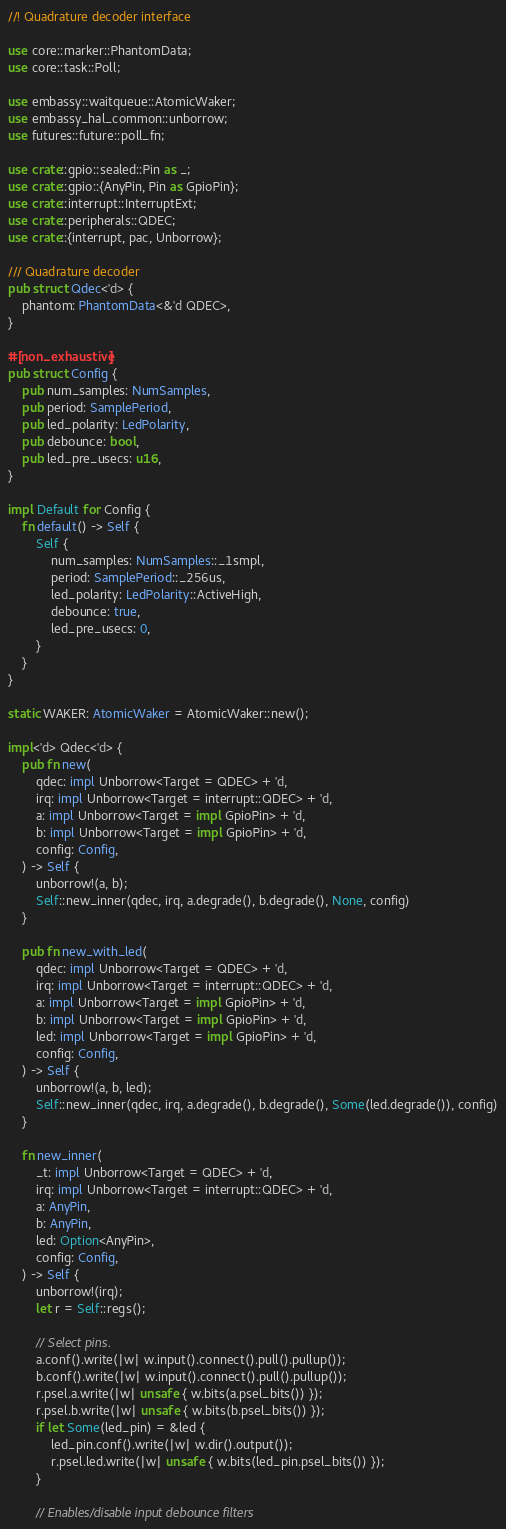<code> <loc_0><loc_0><loc_500><loc_500><_Rust_>//! Quadrature decoder interface

use core::marker::PhantomData;
use core::task::Poll;

use embassy::waitqueue::AtomicWaker;
use embassy_hal_common::unborrow;
use futures::future::poll_fn;

use crate::gpio::sealed::Pin as _;
use crate::gpio::{AnyPin, Pin as GpioPin};
use crate::interrupt::InterruptExt;
use crate::peripherals::QDEC;
use crate::{interrupt, pac, Unborrow};

/// Quadrature decoder
pub struct Qdec<'d> {
    phantom: PhantomData<&'d QDEC>,
}

#[non_exhaustive]
pub struct Config {
    pub num_samples: NumSamples,
    pub period: SamplePeriod,
    pub led_polarity: LedPolarity,
    pub debounce: bool,
    pub led_pre_usecs: u16,
}

impl Default for Config {
    fn default() -> Self {
        Self {
            num_samples: NumSamples::_1smpl,
            period: SamplePeriod::_256us,
            led_polarity: LedPolarity::ActiveHigh,
            debounce: true,
            led_pre_usecs: 0,
        }
    }
}

static WAKER: AtomicWaker = AtomicWaker::new();

impl<'d> Qdec<'d> {
    pub fn new(
        qdec: impl Unborrow<Target = QDEC> + 'd,
        irq: impl Unborrow<Target = interrupt::QDEC> + 'd,
        a: impl Unborrow<Target = impl GpioPin> + 'd,
        b: impl Unborrow<Target = impl GpioPin> + 'd,
        config: Config,
    ) -> Self {
        unborrow!(a, b);
        Self::new_inner(qdec, irq, a.degrade(), b.degrade(), None, config)
    }

    pub fn new_with_led(
        qdec: impl Unborrow<Target = QDEC> + 'd,
        irq: impl Unborrow<Target = interrupt::QDEC> + 'd,
        a: impl Unborrow<Target = impl GpioPin> + 'd,
        b: impl Unborrow<Target = impl GpioPin> + 'd,
        led: impl Unborrow<Target = impl GpioPin> + 'd,
        config: Config,
    ) -> Self {
        unborrow!(a, b, led);
        Self::new_inner(qdec, irq, a.degrade(), b.degrade(), Some(led.degrade()), config)
    }

    fn new_inner(
        _t: impl Unborrow<Target = QDEC> + 'd,
        irq: impl Unborrow<Target = interrupt::QDEC> + 'd,
        a: AnyPin,
        b: AnyPin,
        led: Option<AnyPin>,
        config: Config,
    ) -> Self {
        unborrow!(irq);
        let r = Self::regs();

        // Select pins.
        a.conf().write(|w| w.input().connect().pull().pullup());
        b.conf().write(|w| w.input().connect().pull().pullup());
        r.psel.a.write(|w| unsafe { w.bits(a.psel_bits()) });
        r.psel.b.write(|w| unsafe { w.bits(b.psel_bits()) });
        if let Some(led_pin) = &led {
            led_pin.conf().write(|w| w.dir().output());
            r.psel.led.write(|w| unsafe { w.bits(led_pin.psel_bits()) });
        }

        // Enables/disable input debounce filters</code> 